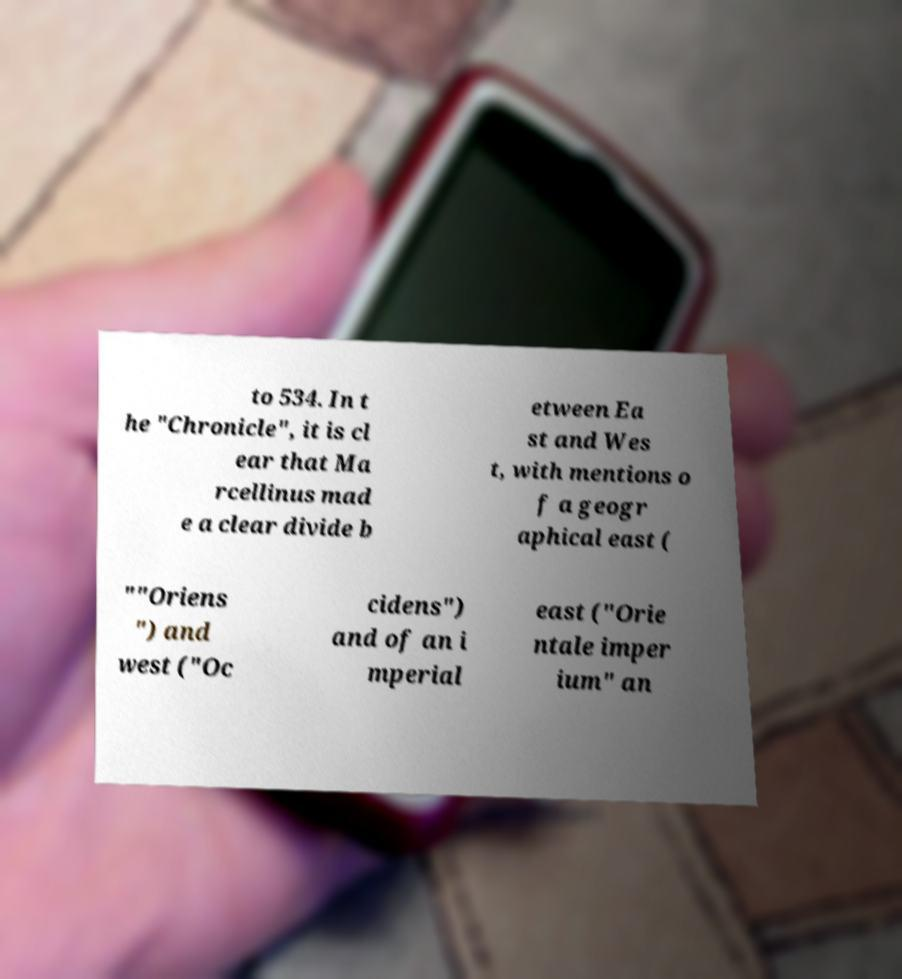For documentation purposes, I need the text within this image transcribed. Could you provide that? to 534. In t he "Chronicle", it is cl ear that Ma rcellinus mad e a clear divide b etween Ea st and Wes t, with mentions o f a geogr aphical east ( ""Oriens ") and west ("Oc cidens") and of an i mperial east ("Orie ntale imper ium" an 